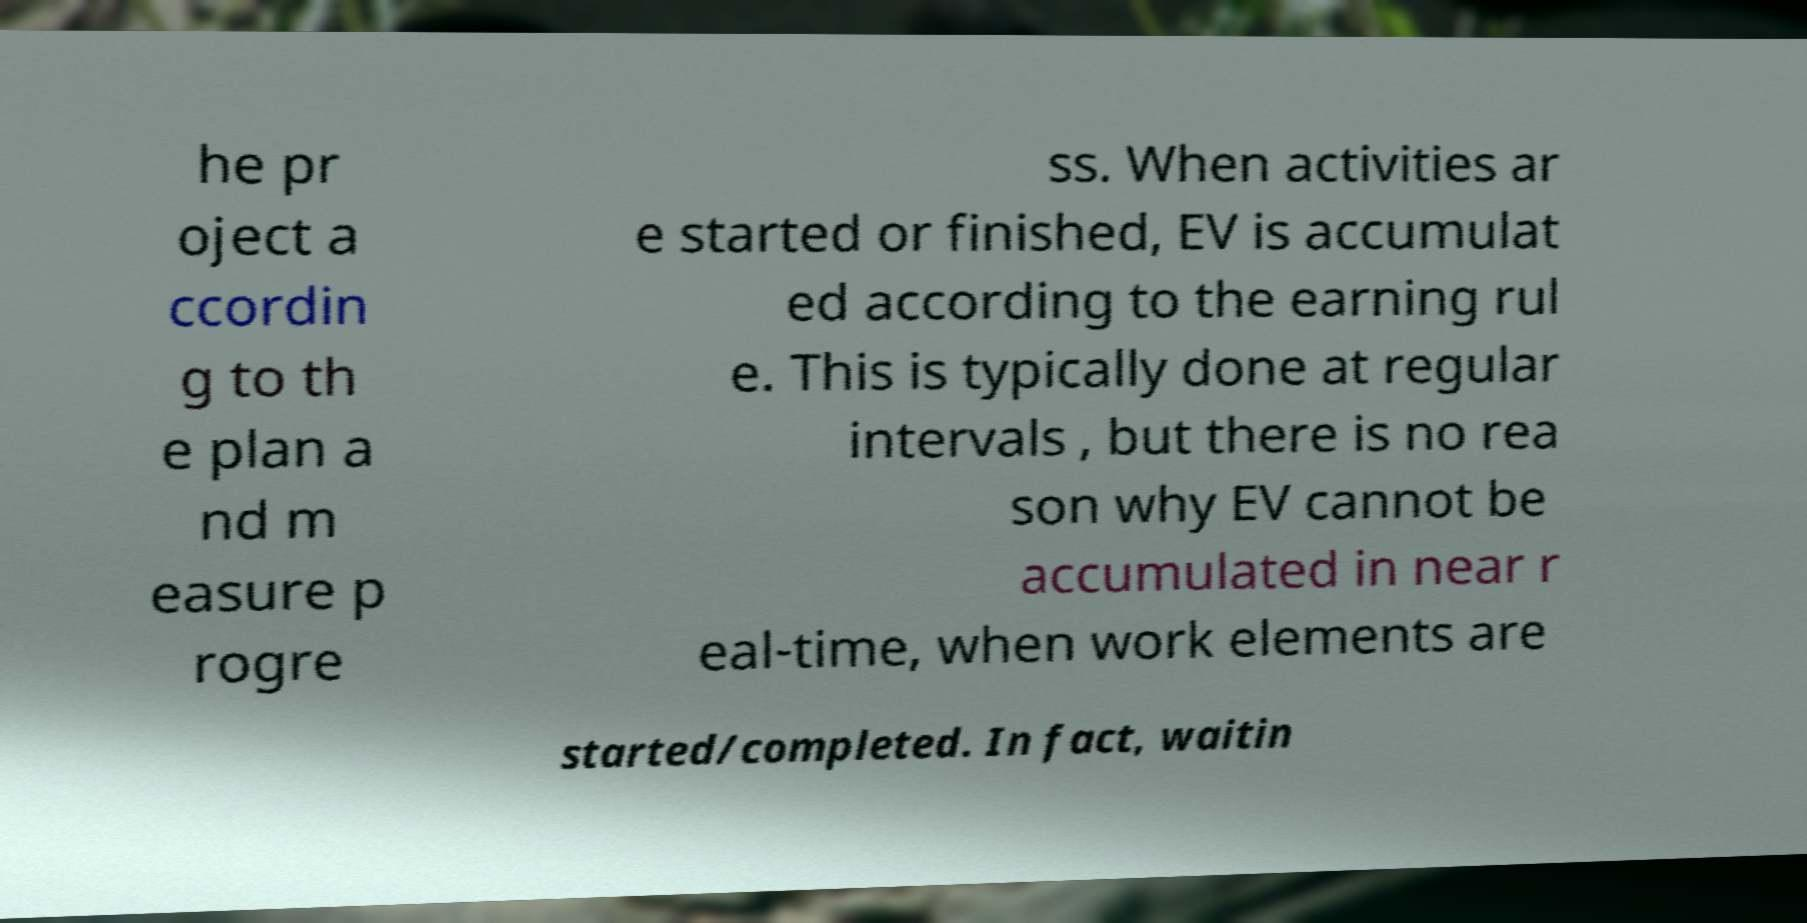Can you accurately transcribe the text from the provided image for me? he pr oject a ccordin g to th e plan a nd m easure p rogre ss. When activities ar e started or finished, EV is accumulat ed according to the earning rul e. This is typically done at regular intervals , but there is no rea son why EV cannot be accumulated in near r eal-time, when work elements are started/completed. In fact, waitin 